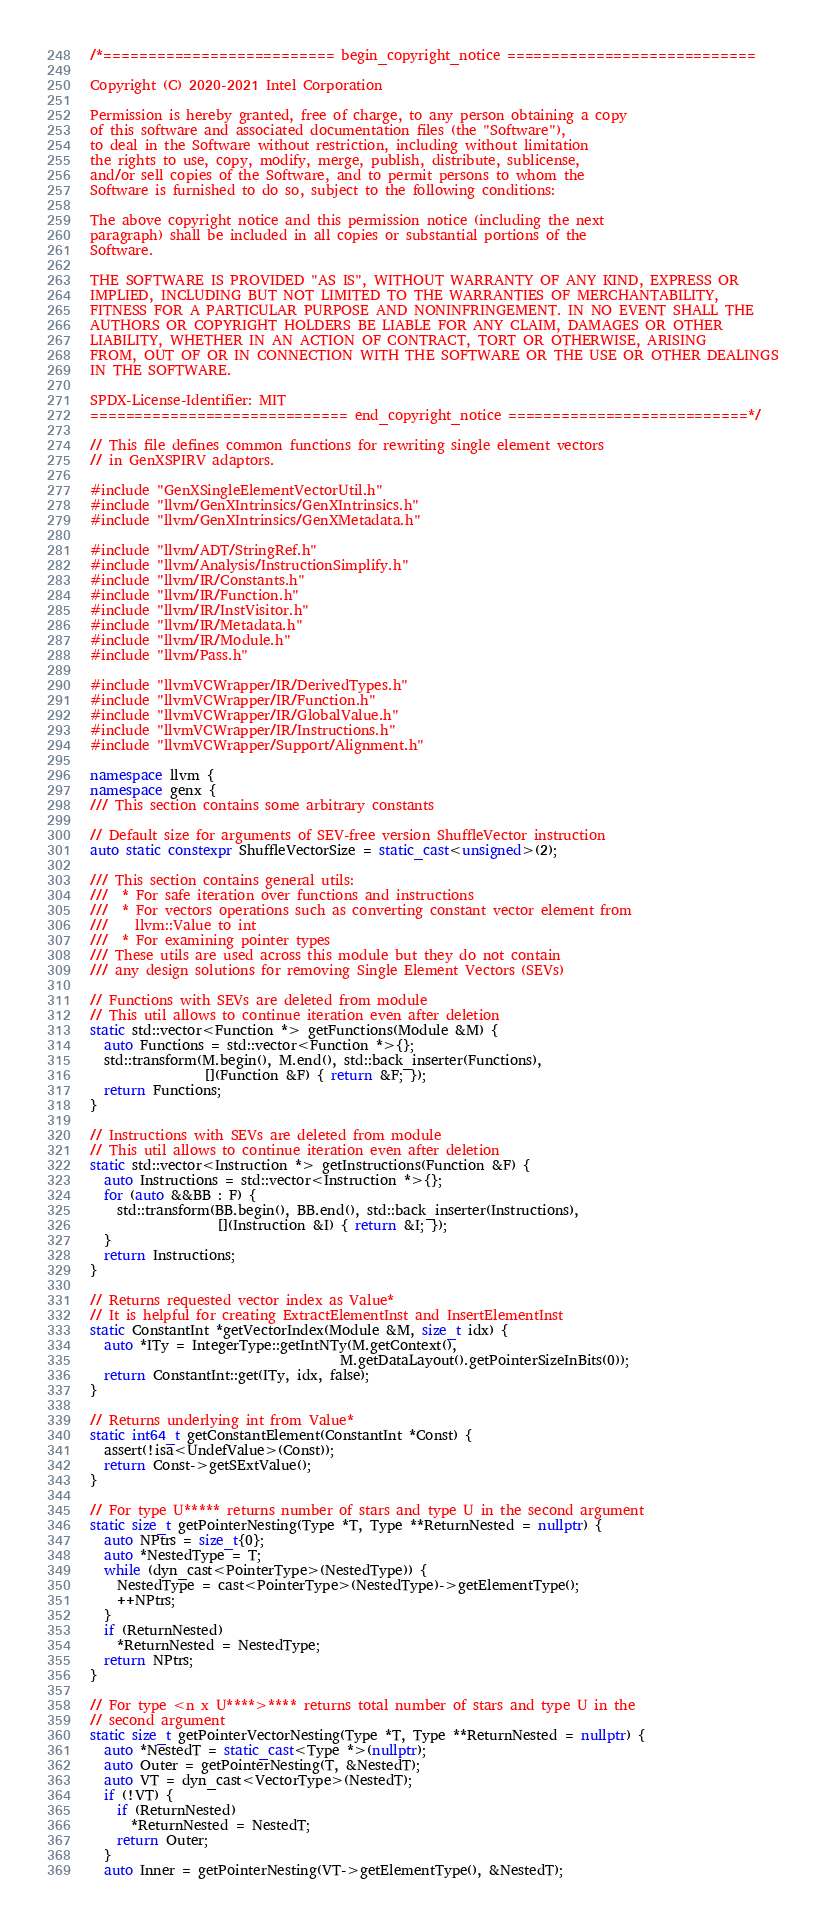<code> <loc_0><loc_0><loc_500><loc_500><_C++_>/*========================== begin_copyright_notice ============================

Copyright (C) 2020-2021 Intel Corporation

Permission is hereby granted, free of charge, to any person obtaining a copy
of this software and associated documentation files (the "Software"),
to deal in the Software without restriction, including without limitation
the rights to use, copy, modify, merge, publish, distribute, sublicense,
and/or sell copies of the Software, and to permit persons to whom the
Software is furnished to do so, subject to the following conditions:

The above copyright notice and this permission notice (including the next
paragraph) shall be included in all copies or substantial portions of the
Software.

THE SOFTWARE IS PROVIDED "AS IS", WITHOUT WARRANTY OF ANY KIND, EXPRESS OR
IMPLIED, INCLUDING BUT NOT LIMITED TO THE WARRANTIES OF MERCHANTABILITY,
FITNESS FOR A PARTICULAR PURPOSE AND NONINFRINGEMENT. IN NO EVENT SHALL THE
AUTHORS OR COPYRIGHT HOLDERS BE LIABLE FOR ANY CLAIM, DAMAGES OR OTHER
LIABILITY, WHETHER IN AN ACTION OF CONTRACT, TORT OR OTHERWISE, ARISING
FROM, OUT OF OR IN CONNECTION WITH THE SOFTWARE OR THE USE OR OTHER DEALINGS
IN THE SOFTWARE.

SPDX-License-Identifier: MIT
============================= end_copyright_notice ===========================*/

// This file defines common functions for rewriting single element vectors
// in GenXSPIRV adaptors.

#include "GenXSingleElementVectorUtil.h"
#include "llvm/GenXIntrinsics/GenXIntrinsics.h"
#include "llvm/GenXIntrinsics/GenXMetadata.h"

#include "llvm/ADT/StringRef.h"
#include "llvm/Analysis/InstructionSimplify.h"
#include "llvm/IR/Constants.h"
#include "llvm/IR/Function.h"
#include "llvm/IR/InstVisitor.h"
#include "llvm/IR/Metadata.h"
#include "llvm/IR/Module.h"
#include "llvm/Pass.h"

#include "llvmVCWrapper/IR/DerivedTypes.h"
#include "llvmVCWrapper/IR/Function.h"
#include "llvmVCWrapper/IR/GlobalValue.h"
#include "llvmVCWrapper/IR/Instructions.h"
#include "llvmVCWrapper/Support/Alignment.h"

namespace llvm {
namespace genx {
/// This section contains some arbitrary constants

// Default size for arguments of SEV-free version ShuffleVector instruction
auto static constexpr ShuffleVectorSize = static_cast<unsigned>(2);

/// This section contains general utils:
///  * For safe iteration over functions and instructions
///  * For vectors operations such as converting constant vector element from
///    llvm::Value to int
///  * For examining pointer types
/// These utils are used across this module but they do not contain
/// any design solutions for removing Single Element Vectors (SEVs)

// Functions with SEVs are deleted from module
// This util allows to continue iteration even after deletion
static std::vector<Function *> getFunctions(Module &M) {
  auto Functions = std::vector<Function *>{};
  std::transform(M.begin(), M.end(), std::back_inserter(Functions),
                 [](Function &F) { return &F; });
  return Functions;
}

// Instructions with SEVs are deleted from module
// This util allows to continue iteration even after deletion
static std::vector<Instruction *> getInstructions(Function &F) {
  auto Instructions = std::vector<Instruction *>{};
  for (auto &&BB : F) {
    std::transform(BB.begin(), BB.end(), std::back_inserter(Instructions),
                   [](Instruction &I) { return &I; });
  }
  return Instructions;
}

// Returns requested vector index as Value*
// It is helpful for creating ExtractElementInst and InsertElementInst
static ConstantInt *getVectorIndex(Module &M, size_t idx) {
  auto *ITy = IntegerType::getIntNTy(M.getContext(),
                                     M.getDataLayout().getPointerSizeInBits(0));
  return ConstantInt::get(ITy, idx, false);
}

// Returns underlying int from Value*
static int64_t getConstantElement(ConstantInt *Const) {
  assert(!isa<UndefValue>(Const));
  return Const->getSExtValue();
}

// For type U***** returns number of stars and type U in the second argument
static size_t getPointerNesting(Type *T, Type **ReturnNested = nullptr) {
  auto NPtrs = size_t{0};
  auto *NestedType = T;
  while (dyn_cast<PointerType>(NestedType)) {
    NestedType = cast<PointerType>(NestedType)->getElementType();
    ++NPtrs;
  }
  if (ReturnNested)
    *ReturnNested = NestedType;
  return NPtrs;
}

// For type <n x U****>**** returns total number of stars and type U in the
// second argument
static size_t getPointerVectorNesting(Type *T, Type **ReturnNested = nullptr) {
  auto *NestedT = static_cast<Type *>(nullptr);
  auto Outer = getPointerNesting(T, &NestedT);
  auto VT = dyn_cast<VectorType>(NestedT);
  if (!VT) {
    if (ReturnNested)
      *ReturnNested = NestedT;
    return Outer;
  }
  auto Inner = getPointerNesting(VT->getElementType(), &NestedT);</code> 